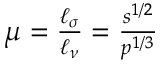Convert formula to latex. <formula><loc_0><loc_0><loc_500><loc_500>\begin{array} { r } { \mu = \frac { \ell _ { \sigma } } { \ell _ { \nu } } = \frac { s ^ { 1 / 2 } } { p ^ { 1 / 3 } } } \end{array}</formula> 